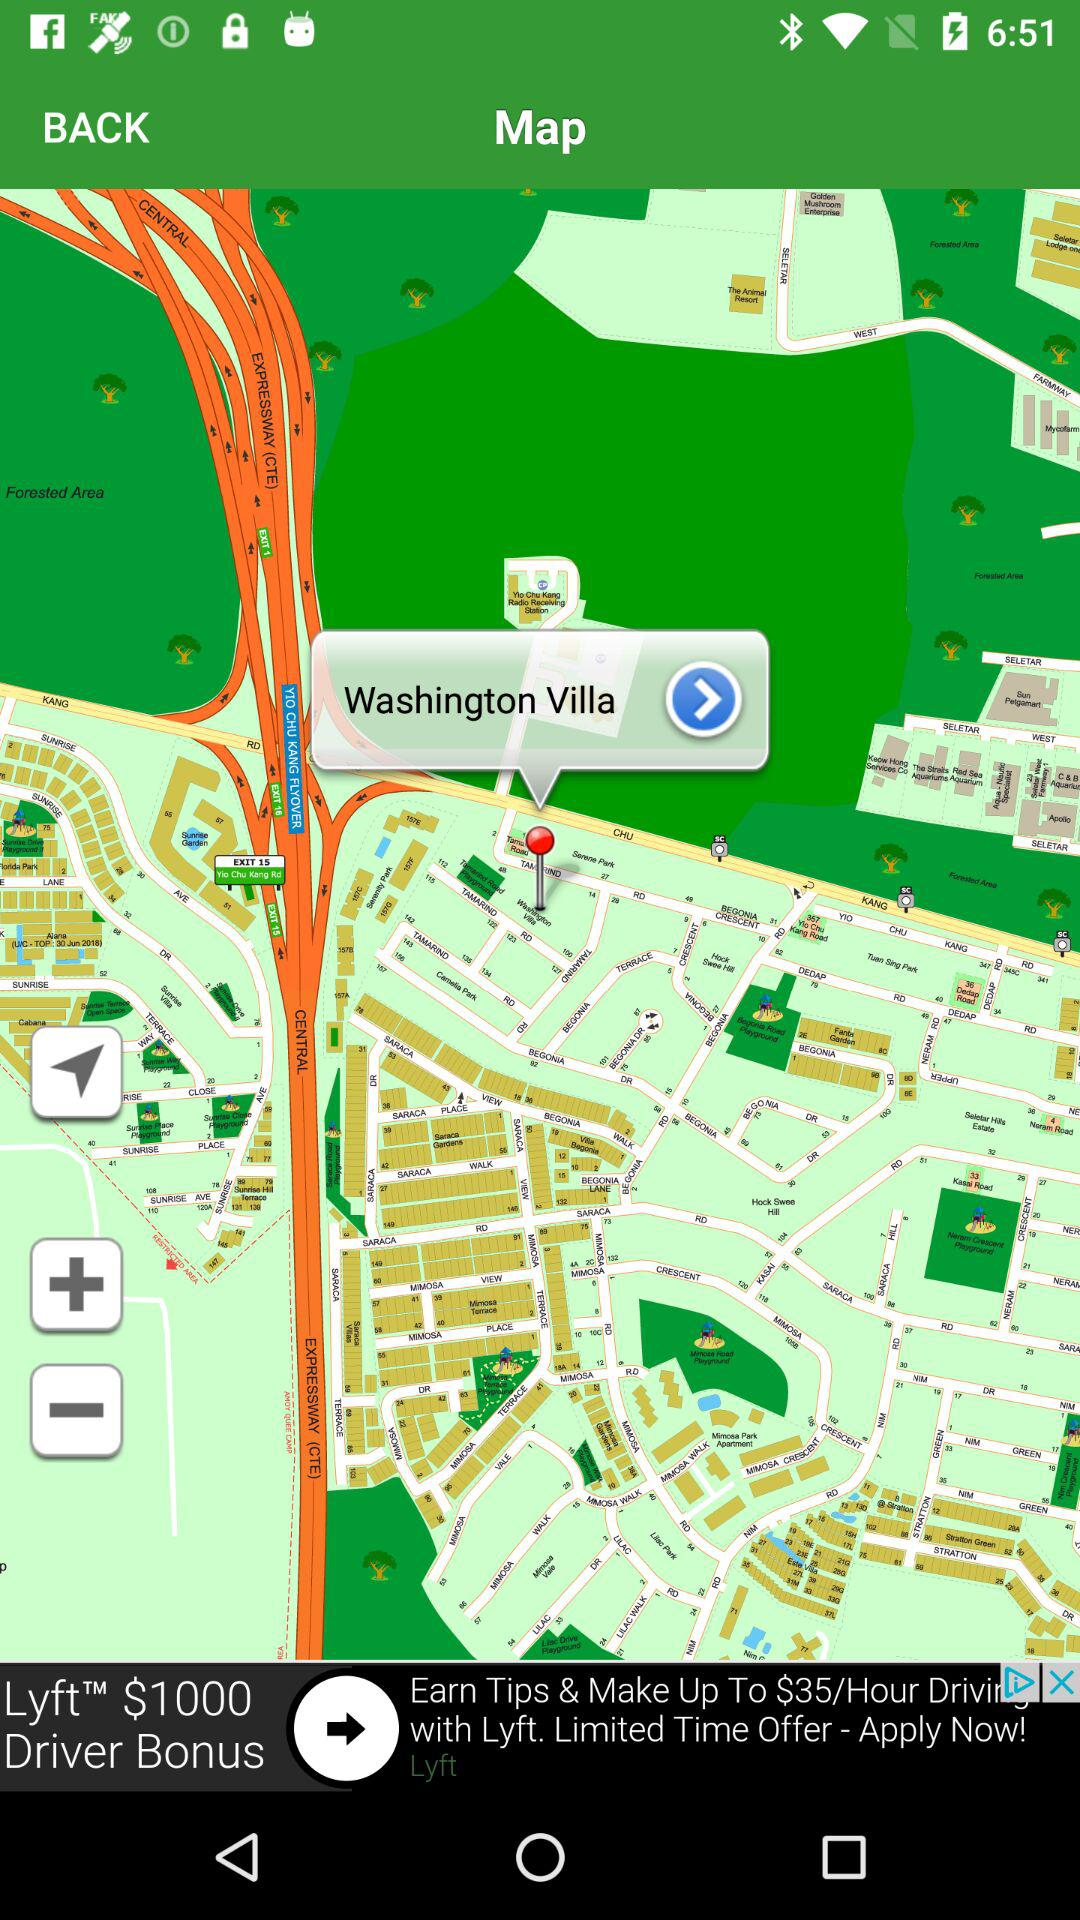How far away is Washington Villa?
When the provided information is insufficient, respond with <no answer>. <no answer> 